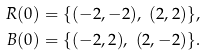Convert formula to latex. <formula><loc_0><loc_0><loc_500><loc_500>R ( 0 ) & = \{ ( - 2 , - 2 ) , \ ( 2 , 2 ) \} , \\ B ( 0 ) & = \{ ( - 2 , 2 ) , \ ( 2 , - 2 ) \} .</formula> 